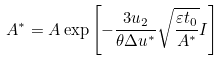Convert formula to latex. <formula><loc_0><loc_0><loc_500><loc_500>A ^ { * } = A \exp \left [ - \frac { 3 u _ { 2 } } { \theta \Delta u ^ { * } } \sqrt { \frac { \varepsilon t _ { 0 } } { A ^ { * } } } I \right ]</formula> 